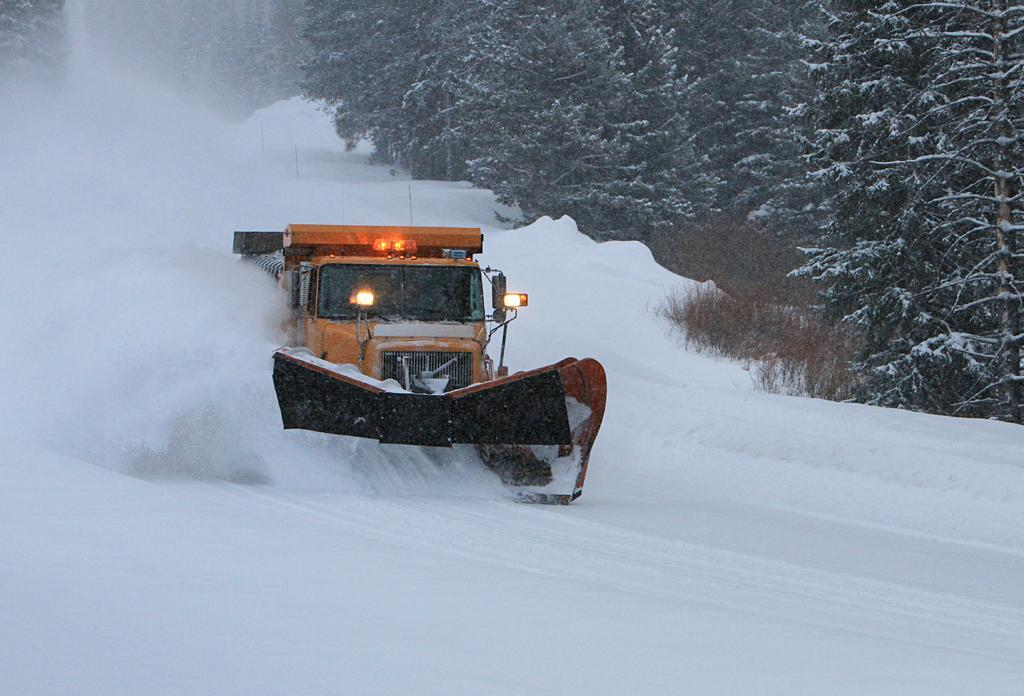What is the condition of the ground in the image? The ground is covered in snow. What type of vehicle is on the snowy ground? There is a yellow-colored vehicle on the snowy ground. What animals can be seen in the image? There are moles visible in the image. What type of vegetation is present in the image? There are trees in the image. What news is being discussed by the moles in the image? There is no indication in the image that the moles are discussing any news. 